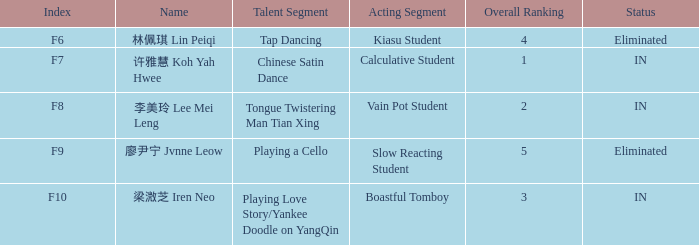What's the acting segment of 林佩琪 lin peiqi's events that are eliminated? Kiasu Student. 